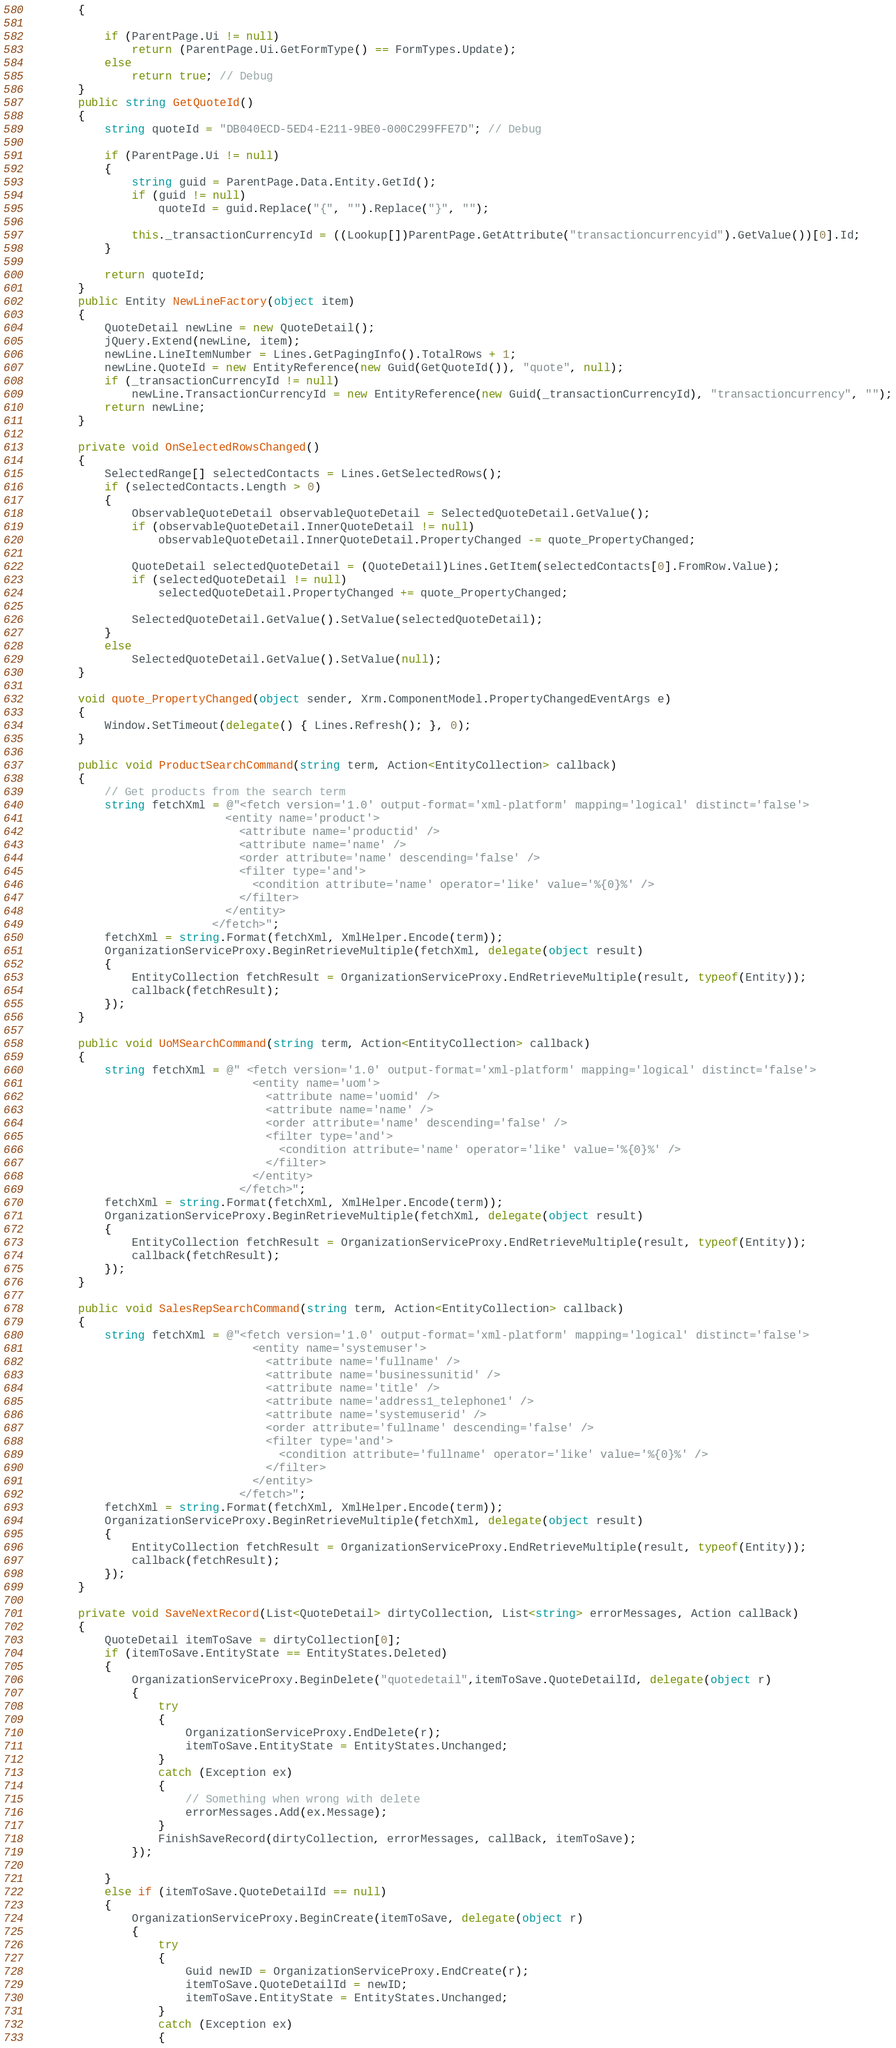Convert code to text. <code><loc_0><loc_0><loc_500><loc_500><_C#_>        {

            if (ParentPage.Ui != null)
                return (ParentPage.Ui.GetFormType() == FormTypes.Update);
            else
                return true; // Debug
        }
        public string GetQuoteId()
        {
            string quoteId = "DB040ECD-5ED4-E211-9BE0-000C299FFE7D"; // Debug

            if (ParentPage.Ui != null)
            {
                string guid = ParentPage.Data.Entity.GetId();
                if (guid != null)
                    quoteId = guid.Replace("{", "").Replace("}", "");

                this._transactionCurrencyId = ((Lookup[])ParentPage.GetAttribute("transactioncurrencyid").GetValue())[0].Id;
            }

            return quoteId;
        }
        public Entity NewLineFactory(object item)
        {
            QuoteDetail newLine = new QuoteDetail();
            jQuery.Extend(newLine, item);
            newLine.LineItemNumber = Lines.GetPagingInfo().TotalRows + 1;
            newLine.QuoteId = new EntityReference(new Guid(GetQuoteId()), "quote", null);
            if (_transactionCurrencyId != null)
                newLine.TransactionCurrencyId = new EntityReference(new Guid(_transactionCurrencyId), "transactioncurrency", "");
            return newLine;
        }

        private void OnSelectedRowsChanged()
        {
            SelectedRange[] selectedContacts = Lines.GetSelectedRows();
            if (selectedContacts.Length > 0)
            {
                ObservableQuoteDetail observableQuoteDetail = SelectedQuoteDetail.GetValue();
                if (observableQuoteDetail.InnerQuoteDetail != null)
                    observableQuoteDetail.InnerQuoteDetail.PropertyChanged -= quote_PropertyChanged;

                QuoteDetail selectedQuoteDetail = (QuoteDetail)Lines.GetItem(selectedContacts[0].FromRow.Value);
                if (selectedQuoteDetail != null)
                    selectedQuoteDetail.PropertyChanged += quote_PropertyChanged;

                SelectedQuoteDetail.GetValue().SetValue(selectedQuoteDetail);
            }
            else
                SelectedQuoteDetail.GetValue().SetValue(null);
        }

        void quote_PropertyChanged(object sender, Xrm.ComponentModel.PropertyChangedEventArgs e)
        {
            Window.SetTimeout(delegate() { Lines.Refresh(); }, 0);
        }

        public void ProductSearchCommand(string term, Action<EntityCollection> callback)
        {
            // Get products from the search term
            string fetchXml = @"<fetch version='1.0' output-format='xml-platform' mapping='logical' distinct='false'>
                              <entity name='product'>
                                <attribute name='productid' />
                                <attribute name='name' />
                                <order attribute='name' descending='false' />
                                <filter type='and'>
                                  <condition attribute='name' operator='like' value='%{0}%' />
                                </filter>
                              </entity>
                            </fetch>";
            fetchXml = string.Format(fetchXml, XmlHelper.Encode(term));
            OrganizationServiceProxy.BeginRetrieveMultiple(fetchXml, delegate(object result)
            {
                EntityCollection fetchResult = OrganizationServiceProxy.EndRetrieveMultiple(result, typeof(Entity));
                callback(fetchResult);
            });
        }

        public void UoMSearchCommand(string term, Action<EntityCollection> callback)
        {
            string fetchXml = @" <fetch version='1.0' output-format='xml-platform' mapping='logical' distinct='false'>
                                  <entity name='uom'>
                                    <attribute name='uomid' />
                                    <attribute name='name' />
                                    <order attribute='name' descending='false' />
                                    <filter type='and'>
                                      <condition attribute='name' operator='like' value='%{0}%' />
                                    </filter>
                                  </entity>
                                </fetch>";
            fetchXml = string.Format(fetchXml, XmlHelper.Encode(term));
            OrganizationServiceProxy.BeginRetrieveMultiple(fetchXml, delegate(object result)
            {
                EntityCollection fetchResult = OrganizationServiceProxy.EndRetrieveMultiple(result, typeof(Entity));
                callback(fetchResult);
            });
        }

        public void SalesRepSearchCommand(string term, Action<EntityCollection> callback)
        {
            string fetchXml = @"<fetch version='1.0' output-format='xml-platform' mapping='logical' distinct='false'>
                                  <entity name='systemuser'>
                                    <attribute name='fullname' />
                                    <attribute name='businessunitid' />
                                    <attribute name='title' />
                                    <attribute name='address1_telephone1' />
                                    <attribute name='systemuserid' />
                                    <order attribute='fullname' descending='false' />
                                    <filter type='and'>
                                      <condition attribute='fullname' operator='like' value='%{0}%' />
                                    </filter>
                                  </entity>
                                </fetch>";
            fetchXml = string.Format(fetchXml, XmlHelper.Encode(term));
            OrganizationServiceProxy.BeginRetrieveMultiple(fetchXml, delegate(object result)
            {
                EntityCollection fetchResult = OrganizationServiceProxy.EndRetrieveMultiple(result, typeof(Entity));
                callback(fetchResult);
            });
        }

        private void SaveNextRecord(List<QuoteDetail> dirtyCollection, List<string> errorMessages, Action callBack)
        {
            QuoteDetail itemToSave = dirtyCollection[0];
            if (itemToSave.EntityState == EntityStates.Deleted)
            {
                OrganizationServiceProxy.BeginDelete("quotedetail",itemToSave.QuoteDetailId, delegate(object r)
                {
                    try
                    {
                        OrganizationServiceProxy.EndDelete(r);
                        itemToSave.EntityState = EntityStates.Unchanged;
                    }
                    catch (Exception ex)
                    {
                        // Something when wrong with delete
                        errorMessages.Add(ex.Message);
                    }
                    FinishSaveRecord(dirtyCollection, errorMessages, callBack, itemToSave);
                });

            }
            else if (itemToSave.QuoteDetailId == null)
            {
                OrganizationServiceProxy.BeginCreate(itemToSave, delegate(object r)
                {
                    try
                    {
                        Guid newID = OrganizationServiceProxy.EndCreate(r);
                        itemToSave.QuoteDetailId = newID;
                        itemToSave.EntityState = EntityStates.Unchanged;
                    }
                    catch (Exception ex)
                    {</code> 